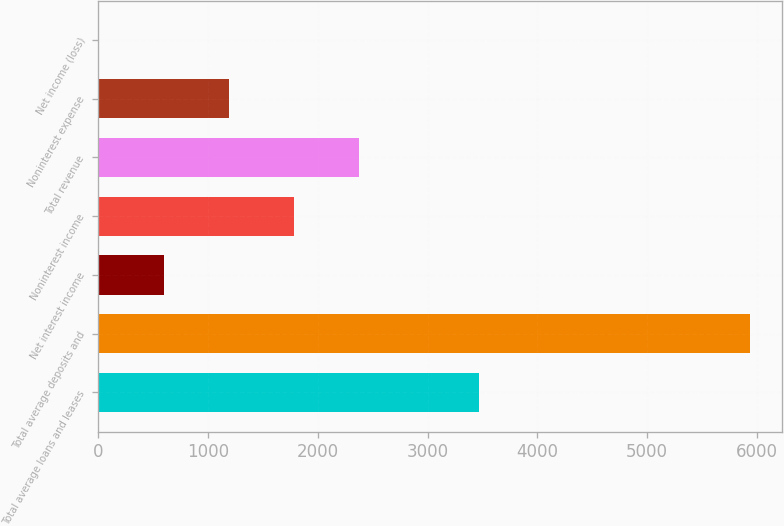Convert chart. <chart><loc_0><loc_0><loc_500><loc_500><bar_chart><fcel>Total average loans and leases<fcel>Total average deposits and<fcel>Net interest income<fcel>Noninterest income<fcel>Total revenue<fcel>Noninterest expense<fcel>Net income (loss)<nl><fcel>3469<fcel>5933<fcel>594.2<fcel>1780.6<fcel>2373.8<fcel>1187.4<fcel>1<nl></chart> 